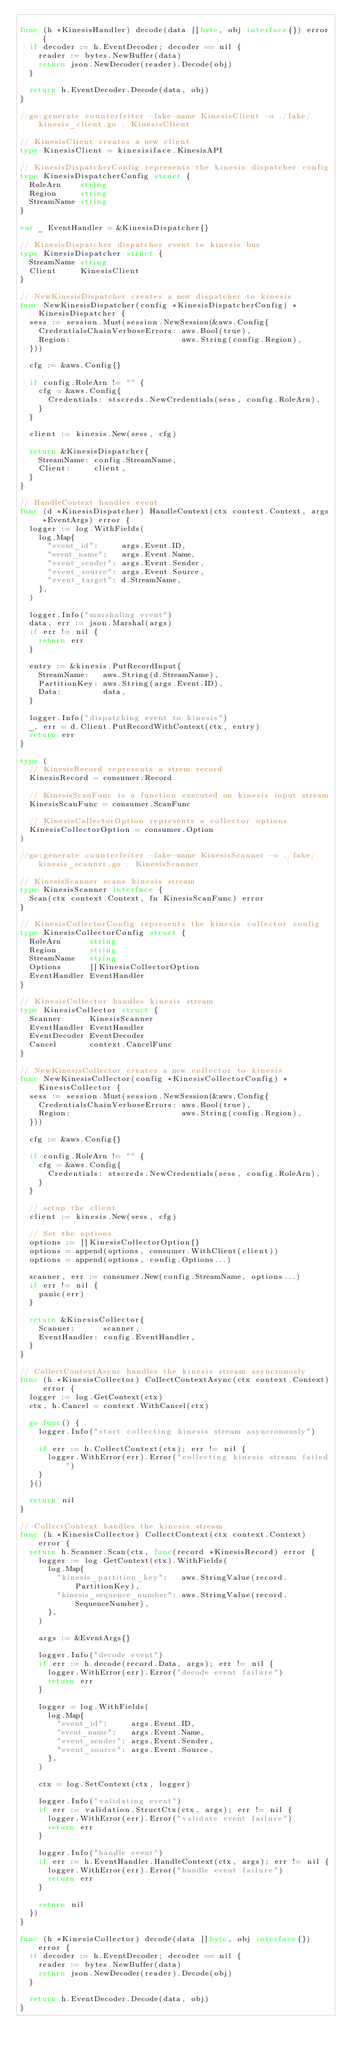Convert code to text. <code><loc_0><loc_0><loc_500><loc_500><_Go_>
func (h *KinesisHandler) decode(data []byte, obj interface{}) error {
	if decoder := h.EventDecoder; decoder == nil {
		reader := bytes.NewBuffer(data)
		return json.NewDecoder(reader).Decode(obj)
	}

	return h.EventDecoder.Decode(data, obj)
}

//go:generate counterfeiter -fake-name KinesisClient -o ./fake/kinesis_client.go . KinesisClient

// KinesisClient creates a new client
type KinesisClient = kinesisiface.KinesisAPI

// KinesisDispatcherConfig represents the kinesis dispatcher config
type KinesisDispatcherConfig struct {
	RoleArn    string
	Region     string
	StreamName string
}

var _ EventHandler = &KinesisDispatcher{}

// KinesisDispatcher dispatches event to kinesis bus
type KinesisDispatcher struct {
	StreamName string
	Client     KinesisClient
}

// NewKinesisDispatcher creates a new dispatcher to kinesis
func NewKinesisDispatcher(config *KinesisDispatcherConfig) *KinesisDispatcher {
	sess := session.Must(session.NewSession(&aws.Config{
		CredentialsChainVerboseErrors: aws.Bool(true),
		Region:                        aws.String(config.Region),
	}))

	cfg := &aws.Config{}

	if config.RoleArn != "" {
		cfg = &aws.Config{
			Credentials: stscreds.NewCredentials(sess, config.RoleArn),
		}
	}

	client := kinesis.New(sess, cfg)

	return &KinesisDispatcher{
		StreamName: config.StreamName,
		Client:     client,
	}
}

// HandleContext handles event
func (d *KinesisDispatcher) HandleContext(ctx context.Context, args *EventArgs) error {
	logger := log.WithFields(
		log.Map{
			"event_id":     args.Event.ID,
			"event_name":   args.Event.Name,
			"event_sender": args.Event.Sender,
			"event_source": args.Event.Source,
			"event_target": d.StreamName,
		},
	)

	logger.Info("marshaling event")
	data, err := json.Marshal(args)
	if err != nil {
		return err
	}

	entry := &kinesis.PutRecordInput{
		StreamName:   aws.String(d.StreamName),
		PartitionKey: aws.String(args.Event.ID),
		Data:         data,
	}

	logger.Info("dispatching event to kinesis")
	_, err = d.Client.PutRecordWithContext(ctx, entry)
	return err
}

type (
	// KinesisRecord represents a strem record
	KinesisRecord = consumer.Record

	// KinesisScanFunc is a function executed on kinesis input stream
	KinesisScanFunc = consumer.ScanFunc

	// KinesisCollectorOption represents a collector options
	KinesisCollectorOption = consumer.Option
)

//go:generate counterfeiter -fake-name KinesisScanner -o ./fake/kinesis_scanner.go . KinesisScanner

// KinesisScanner scans kinesis stream
type KinesisScanner interface {
	Scan(ctx context.Context, fn KinesisScanFunc) error
}

// KinesisCollectorConfig represents the kinesis collector config
type KinesisCollectorConfig struct {
	RoleArn      string
	Region       string
	StreamName   string
	Options      []KinesisCollectorOption
	EventHandler EventHandler
}

// KinesisCollector handles kinesis stream
type KinesisCollector struct {
	Scanner      KinesisScanner
	EventHandler EventHandler
	EventDecoder EventDecoder
	Cancel       context.CancelFunc
}

// NewKinesisCollector creates a new collector to kinesis
func NewKinesisCollector(config *KinesisCollectorConfig) *KinesisCollector {
	sess := session.Must(session.NewSession(&aws.Config{
		CredentialsChainVerboseErrors: aws.Bool(true),
		Region:                        aws.String(config.Region),
	}))

	cfg := &aws.Config{}

	if config.RoleArn != "" {
		cfg = &aws.Config{
			Credentials: stscreds.NewCredentials(sess, config.RoleArn),
		}
	}

	// setup the client
	client := kinesis.New(sess, cfg)

	// Set the options
	options := []KinesisCollectorOption{}
	options = append(options, consumer.WithClient(client))
	options = append(options, config.Options...)

	scanner, err := consumer.New(config.StreamName, options...)
	if err != nil {
		panic(err)
	}

	return &KinesisCollector{
		Scanner:      scanner,
		EventHandler: config.EventHandler,
	}
}

// CollectContextAsync handles the kinesis stream asyncronosly
func (h *KinesisCollector) CollectContextAsync(ctx context.Context) error {
	logger := log.GetContext(ctx)
	ctx, h.Cancel = context.WithCancel(ctx)

	go func() {
		logger.Info("start collecting kinesis stream asyncronously")

		if err := h.CollectContext(ctx); err != nil {
			logger.WithError(err).Error("collecting kinesis stream failed")
		}
	}()

	return nil
}

// CollectContext handles the kinesis stream
func (h *KinesisCollector) CollectContext(ctx context.Context) error {
	return h.Scanner.Scan(ctx, func(record *KinesisRecord) error {
		logger := log.GetContext(ctx).WithFields(
			log.Map{
				"kinesis_partition_key":   aws.StringValue(record.PartitionKey),
				"kinesis_sequence_number": aws.StringValue(record.SequenceNumber),
			},
		)

		args := &EventArgs{}

		logger.Info("decode event")
		if err := h.decode(record.Data, args); err != nil {
			logger.WithError(err).Error("decode event failure")
			return err
		}

		logger = log.WithFields(
			log.Map{
				"event_id":     args.Event.ID,
				"event_name":   args.Event.Name,
				"event_sender": args.Event.Sender,
				"event_source": args.Event.Source,
			},
		)

		ctx = log.SetContext(ctx, logger)

		logger.Info("validating event")
		if err := validation.StructCtx(ctx, args); err != nil {
			logger.WithError(err).Error("validate event failure")
			return err
		}

		logger.Info("handle event")
		if err := h.EventHandler.HandleContext(ctx, args); err != nil {
			logger.WithError(err).Error("handle event failure")
			return err
		}

		return nil
	})
}

func (h *KinesisCollector) decode(data []byte, obj interface{}) error {
	if decoder := h.EventDecoder; decoder == nil {
		reader := bytes.NewBuffer(data)
		return json.NewDecoder(reader).Decode(obj)
	}

	return h.EventDecoder.Decode(data, obj)
}
</code> 